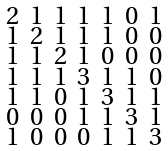Convert formula to latex. <formula><loc_0><loc_0><loc_500><loc_500>\begin{smallmatrix} 2 & 1 & 1 & 1 & 1 & 0 & 1 \\ 1 & 2 & 1 & 1 & 1 & 0 & 0 \\ 1 & 1 & 2 & 1 & 0 & 0 & 0 \\ 1 & 1 & 1 & 3 & 1 & 1 & 0 \\ 1 & 1 & 0 & 1 & 3 & 1 & 1 \\ 0 & 0 & 0 & 1 & 1 & 3 & 1 \\ 1 & 0 & 0 & 0 & 1 & 1 & 3 \end{smallmatrix}</formula> 